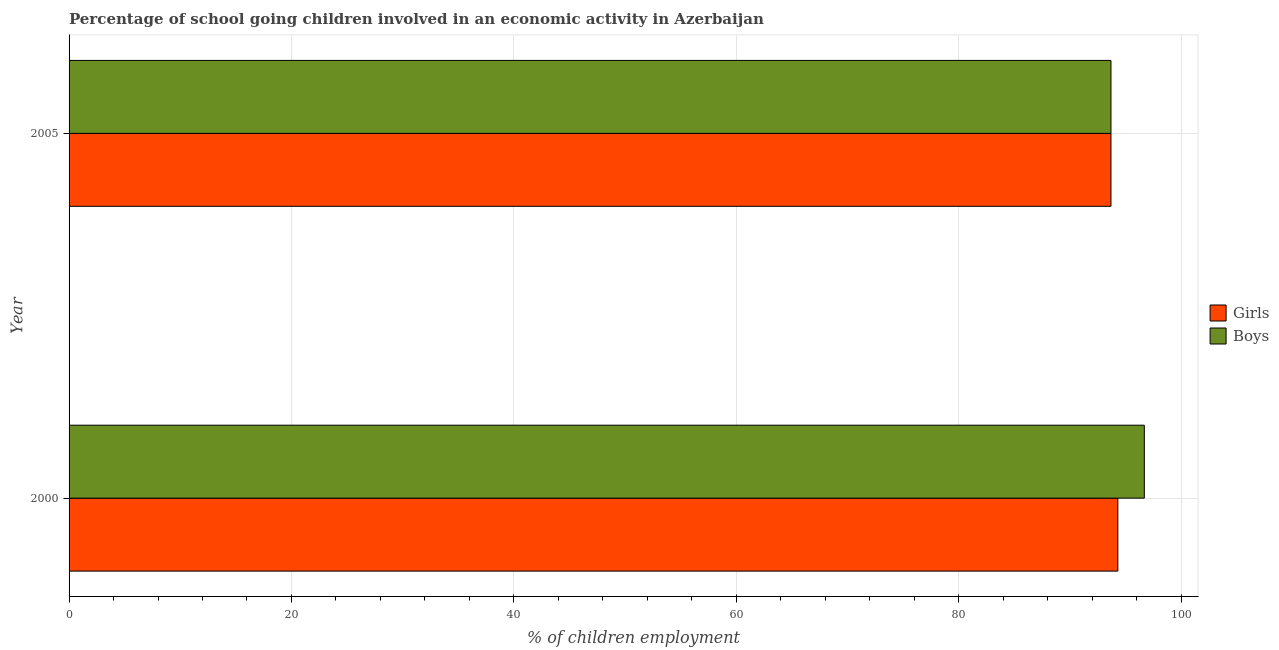How many different coloured bars are there?
Offer a terse response. 2. How many bars are there on the 2nd tick from the top?
Your answer should be very brief. 2. What is the percentage of school going boys in 2005?
Give a very brief answer. 93.7. Across all years, what is the maximum percentage of school going boys?
Keep it short and to the point. 96.7. Across all years, what is the minimum percentage of school going boys?
Provide a succinct answer. 93.7. In which year was the percentage of school going boys minimum?
Ensure brevity in your answer.  2005. What is the total percentage of school going boys in the graph?
Provide a short and direct response. 190.4. What is the difference between the percentage of school going girls in 2000 and the percentage of school going boys in 2005?
Provide a succinct answer. 0.62. What is the average percentage of school going boys per year?
Your answer should be very brief. 95.2. In how many years, is the percentage of school going girls greater than 52 %?
Provide a succinct answer. 2. What does the 2nd bar from the top in 2005 represents?
Keep it short and to the point. Girls. What does the 2nd bar from the bottom in 2000 represents?
Your response must be concise. Boys. Are all the bars in the graph horizontal?
Ensure brevity in your answer.  Yes. How many years are there in the graph?
Provide a short and direct response. 2. What is the difference between two consecutive major ticks on the X-axis?
Offer a terse response. 20. Where does the legend appear in the graph?
Ensure brevity in your answer.  Center right. How many legend labels are there?
Ensure brevity in your answer.  2. How are the legend labels stacked?
Your response must be concise. Vertical. What is the title of the graph?
Provide a succinct answer. Percentage of school going children involved in an economic activity in Azerbaijan. What is the label or title of the X-axis?
Your answer should be compact. % of children employment. What is the label or title of the Y-axis?
Offer a very short reply. Year. What is the % of children employment of Girls in 2000?
Keep it short and to the point. 94.32. What is the % of children employment in Boys in 2000?
Offer a terse response. 96.7. What is the % of children employment of Girls in 2005?
Offer a terse response. 93.7. What is the % of children employment in Boys in 2005?
Your response must be concise. 93.7. Across all years, what is the maximum % of children employment in Girls?
Your answer should be compact. 94.32. Across all years, what is the maximum % of children employment of Boys?
Make the answer very short. 96.7. Across all years, what is the minimum % of children employment in Girls?
Make the answer very short. 93.7. Across all years, what is the minimum % of children employment of Boys?
Your answer should be compact. 93.7. What is the total % of children employment in Girls in the graph?
Ensure brevity in your answer.  188.02. What is the total % of children employment of Boys in the graph?
Keep it short and to the point. 190.4. What is the difference between the % of children employment of Girls in 2000 and that in 2005?
Provide a succinct answer. 0.62. What is the difference between the % of children employment in Boys in 2000 and that in 2005?
Your response must be concise. 3. What is the difference between the % of children employment in Girls in 2000 and the % of children employment in Boys in 2005?
Offer a terse response. 0.62. What is the average % of children employment in Girls per year?
Provide a short and direct response. 94.01. What is the average % of children employment of Boys per year?
Your answer should be compact. 95.2. In the year 2000, what is the difference between the % of children employment in Girls and % of children employment in Boys?
Offer a very short reply. -2.38. In the year 2005, what is the difference between the % of children employment in Girls and % of children employment in Boys?
Your answer should be very brief. 0. What is the ratio of the % of children employment of Girls in 2000 to that in 2005?
Provide a short and direct response. 1.01. What is the ratio of the % of children employment of Boys in 2000 to that in 2005?
Provide a short and direct response. 1.03. What is the difference between the highest and the second highest % of children employment in Girls?
Your answer should be compact. 0.62. What is the difference between the highest and the second highest % of children employment in Boys?
Your response must be concise. 3. What is the difference between the highest and the lowest % of children employment in Girls?
Give a very brief answer. 0.62. What is the difference between the highest and the lowest % of children employment of Boys?
Offer a terse response. 3. 